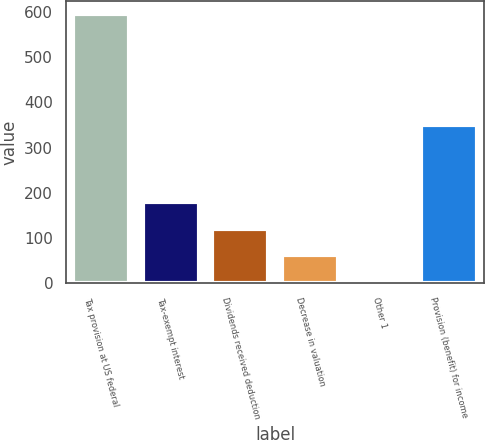Convert chart to OTSL. <chart><loc_0><loc_0><loc_500><loc_500><bar_chart><fcel>Tax provision at US federal<fcel>Tax-exempt interest<fcel>Dividends received deduction<fcel>Decrease in valuation<fcel>Other 1<fcel>Provision (benefit) for income<nl><fcel>595<fcel>179.9<fcel>120.6<fcel>61.3<fcel>2<fcel>350<nl></chart> 